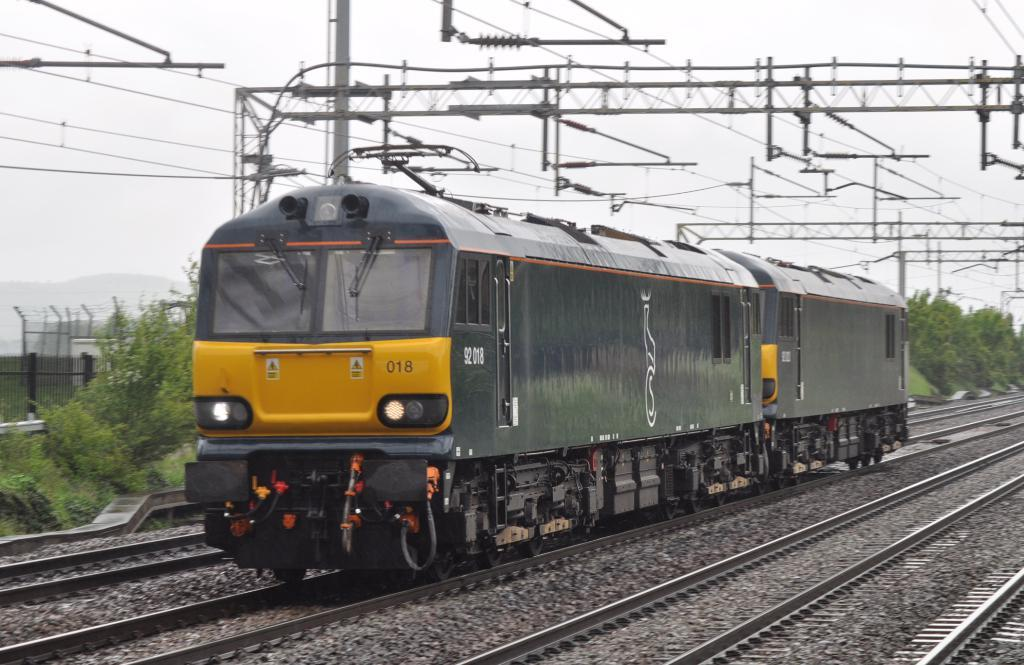<image>
Provide a brief description of the given image. Train 018 is speeding towards it's next stop on a cloudy day. 